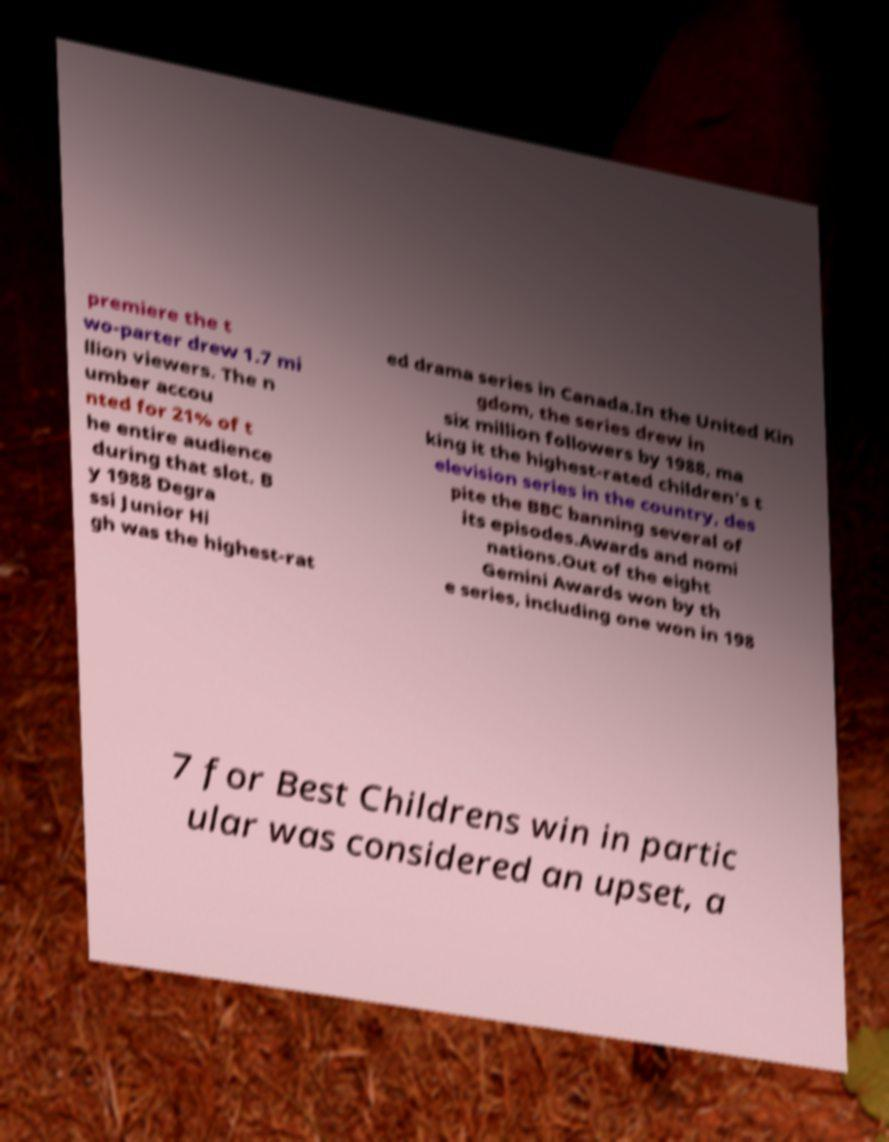Can you accurately transcribe the text from the provided image for me? premiere the t wo-parter drew 1.7 mi llion viewers. The n umber accou nted for 21% of t he entire audience during that slot. B y 1988 Degra ssi Junior Hi gh was the highest-rat ed drama series in Canada.In the United Kin gdom, the series drew in six million followers by 1988, ma king it the highest-rated children's t elevision series in the country, des pite the BBC banning several of its episodes.Awards and nomi nations.Out of the eight Gemini Awards won by th e series, including one won in 198 7 for Best Childrens win in partic ular was considered an upset, a 